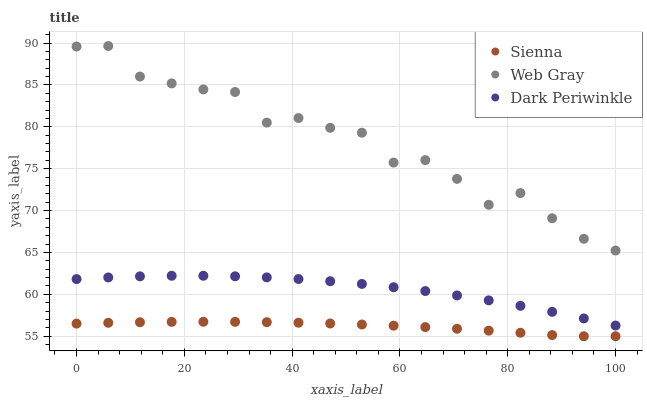Does Sienna have the minimum area under the curve?
Answer yes or no. Yes. Does Web Gray have the maximum area under the curve?
Answer yes or no. Yes. Does Dark Periwinkle have the minimum area under the curve?
Answer yes or no. No. Does Dark Periwinkle have the maximum area under the curve?
Answer yes or no. No. Is Sienna the smoothest?
Answer yes or no. Yes. Is Web Gray the roughest?
Answer yes or no. Yes. Is Dark Periwinkle the smoothest?
Answer yes or no. No. Is Dark Periwinkle the roughest?
Answer yes or no. No. Does Sienna have the lowest value?
Answer yes or no. Yes. Does Dark Periwinkle have the lowest value?
Answer yes or no. No. Does Web Gray have the highest value?
Answer yes or no. Yes. Does Dark Periwinkle have the highest value?
Answer yes or no. No. Is Sienna less than Web Gray?
Answer yes or no. Yes. Is Web Gray greater than Dark Periwinkle?
Answer yes or no. Yes. Does Sienna intersect Web Gray?
Answer yes or no. No. 